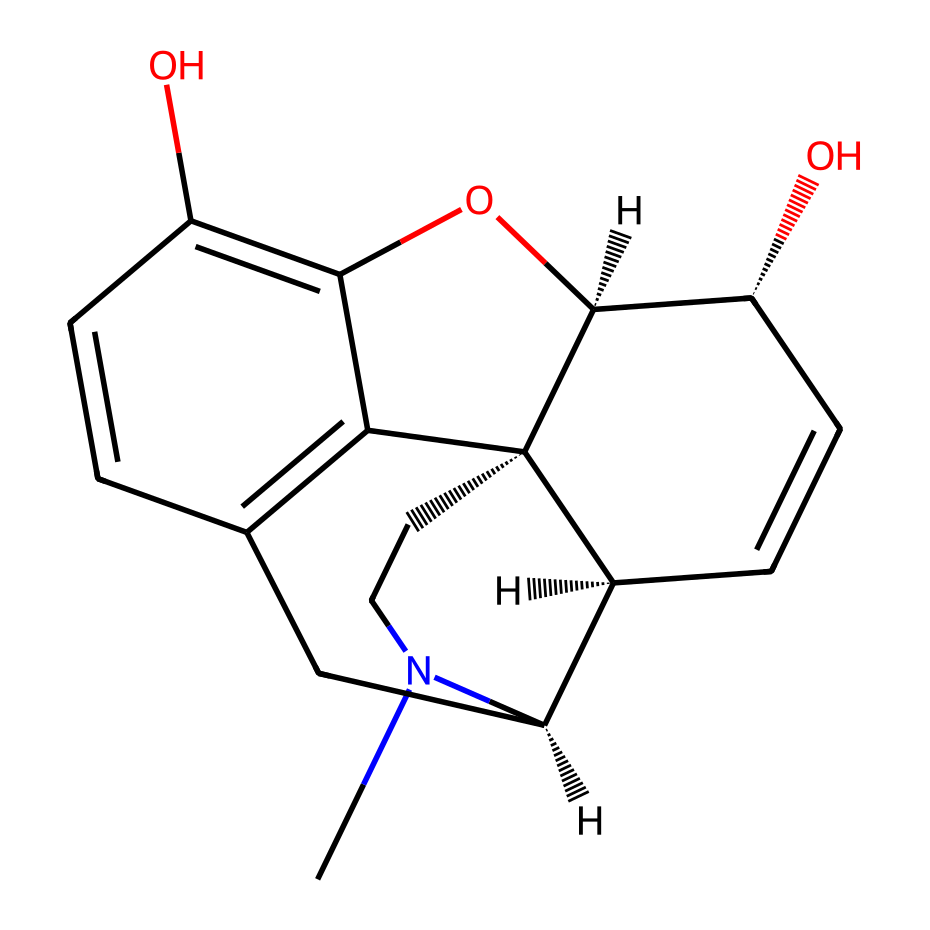What is the primary functional group present in morphine? The visual representation contains a hydroxyl group (-OH) attached to the aromatic ring, which is characteristic of phenolic compounds. Additionally, there is a nitrogen atom indicating the presence of an amine functional group associated with many alkaloids. Thus, the hydroxyl group is a primary functional group here.
Answer: hydroxyl How many nitrogen atoms are present in the structure? The SMILES depicts two nitrogen atoms where they are positioned in the cyclic structure. By counting the nitrogen symbols (N), we find two directly linked to the carbon framework of the molecule.
Answer: two What is the total number of rings in the morphine structure? Analyzing the cyclic components, we can see that the structure comprises five interconnected rings. Counting circular structures within the representation leads us to identify the five distinct rings.
Answer: five What type of compound is morphine categorized as? Morphine is categorized as an opioid alkaloid due to its structure containing a nitrogen atom and its natural origin from the opium poppy. This classification sets it apart as a specific type of alkaloid that interacts with the opioid receptors in the brain.
Answer: opioid alkaloid Which molecular features in morphine contribute to its pain relief properties? The nitrogen atom in the structure allows for binding at opioid receptors, and the hydroxyl groups enhance interactions with biological molecules, contributing to its analgesic effects. These features help morphine mimic natural endogenous ligands.
Answer: nitrogen and hydroxyl groups What is the stereochemistry of morphine based on its structure? The structure includes chiral centers indicated by the '@' symbols in the SMILES, meaning there are specific handedness orientations for some atoms. These chiral centers lead to distinct stereoisomers significant for the biological activity of morphine.
Answer: chiral centers 